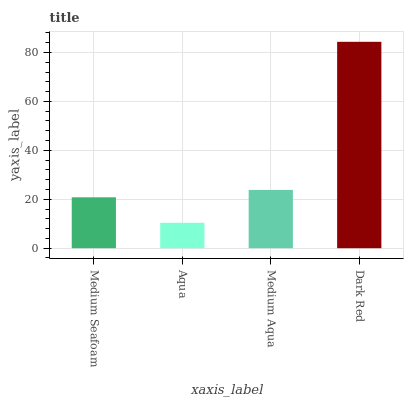Is Aqua the minimum?
Answer yes or no. Yes. Is Dark Red the maximum?
Answer yes or no. Yes. Is Medium Aqua the minimum?
Answer yes or no. No. Is Medium Aqua the maximum?
Answer yes or no. No. Is Medium Aqua greater than Aqua?
Answer yes or no. Yes. Is Aqua less than Medium Aqua?
Answer yes or no. Yes. Is Aqua greater than Medium Aqua?
Answer yes or no. No. Is Medium Aqua less than Aqua?
Answer yes or no. No. Is Medium Aqua the high median?
Answer yes or no. Yes. Is Medium Seafoam the low median?
Answer yes or no. Yes. Is Aqua the high median?
Answer yes or no. No. Is Medium Aqua the low median?
Answer yes or no. No. 